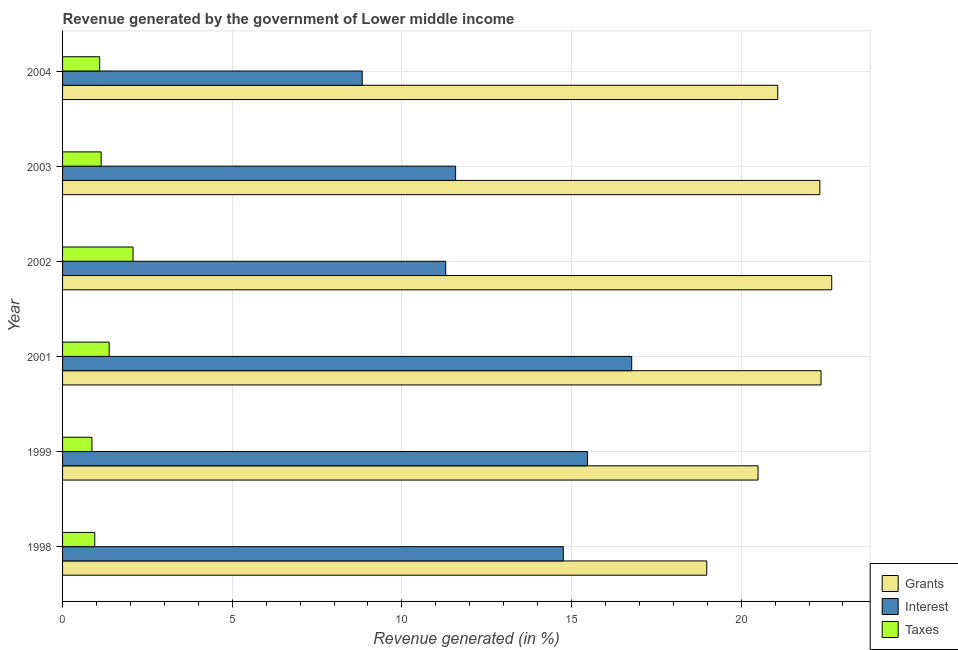How many different coloured bars are there?
Ensure brevity in your answer.  3. How many groups of bars are there?
Your answer should be compact. 6. How many bars are there on the 4th tick from the bottom?
Your answer should be very brief. 3. What is the label of the 4th group of bars from the top?
Your response must be concise. 2001. What is the percentage of revenue generated by taxes in 2003?
Offer a terse response. 1.14. Across all years, what is the maximum percentage of revenue generated by grants?
Your answer should be compact. 22.67. Across all years, what is the minimum percentage of revenue generated by grants?
Your response must be concise. 18.99. What is the total percentage of revenue generated by taxes in the graph?
Provide a succinct answer. 7.5. What is the difference between the percentage of revenue generated by grants in 1999 and that in 2003?
Your answer should be compact. -1.82. What is the difference between the percentage of revenue generated by taxes in 1998 and the percentage of revenue generated by grants in 1999?
Keep it short and to the point. -19.55. What is the average percentage of revenue generated by taxes per year?
Your answer should be very brief. 1.25. In the year 1999, what is the difference between the percentage of revenue generated by grants and percentage of revenue generated by interest?
Your answer should be compact. 5.03. In how many years, is the percentage of revenue generated by interest greater than 16 %?
Your answer should be compact. 1. What is the ratio of the percentage of revenue generated by taxes in 1999 to that in 2001?
Offer a very short reply. 0.63. Is the difference between the percentage of revenue generated by interest in 1999 and 2001 greater than the difference between the percentage of revenue generated by grants in 1999 and 2001?
Offer a very short reply. Yes. What is the difference between the highest and the second highest percentage of revenue generated by taxes?
Make the answer very short. 0.7. What is the difference between the highest and the lowest percentage of revenue generated by grants?
Provide a succinct answer. 3.68. Is the sum of the percentage of revenue generated by interest in 1998 and 2001 greater than the maximum percentage of revenue generated by taxes across all years?
Offer a terse response. Yes. What does the 1st bar from the top in 2004 represents?
Make the answer very short. Taxes. What does the 2nd bar from the bottom in 1998 represents?
Ensure brevity in your answer.  Interest. How many bars are there?
Your answer should be very brief. 18. Are all the bars in the graph horizontal?
Provide a short and direct response. Yes. How many years are there in the graph?
Provide a succinct answer. 6. What is the difference between two consecutive major ticks on the X-axis?
Make the answer very short. 5. Are the values on the major ticks of X-axis written in scientific E-notation?
Your response must be concise. No. Does the graph contain any zero values?
Provide a succinct answer. No. Where does the legend appear in the graph?
Make the answer very short. Bottom right. How many legend labels are there?
Your answer should be compact. 3. How are the legend labels stacked?
Your answer should be very brief. Vertical. What is the title of the graph?
Offer a terse response. Revenue generated by the government of Lower middle income. Does "Ages 50+" appear as one of the legend labels in the graph?
Provide a succinct answer. No. What is the label or title of the X-axis?
Make the answer very short. Revenue generated (in %). What is the Revenue generated (in %) of Grants in 1998?
Offer a terse response. 18.99. What is the Revenue generated (in %) of Interest in 1998?
Your answer should be very brief. 14.76. What is the Revenue generated (in %) of Taxes in 1998?
Your response must be concise. 0.95. What is the Revenue generated (in %) in Grants in 1999?
Your answer should be very brief. 20.5. What is the Revenue generated (in %) of Interest in 1999?
Your answer should be very brief. 15.47. What is the Revenue generated (in %) of Taxes in 1999?
Give a very brief answer. 0.87. What is the Revenue generated (in %) in Grants in 2001?
Make the answer very short. 22.35. What is the Revenue generated (in %) of Interest in 2001?
Keep it short and to the point. 16.77. What is the Revenue generated (in %) of Taxes in 2001?
Offer a very short reply. 1.37. What is the Revenue generated (in %) of Grants in 2002?
Make the answer very short. 22.67. What is the Revenue generated (in %) in Interest in 2002?
Ensure brevity in your answer.  11.29. What is the Revenue generated (in %) of Taxes in 2002?
Make the answer very short. 2.08. What is the Revenue generated (in %) in Grants in 2003?
Make the answer very short. 22.32. What is the Revenue generated (in %) of Interest in 2003?
Your answer should be very brief. 11.58. What is the Revenue generated (in %) of Taxes in 2003?
Ensure brevity in your answer.  1.14. What is the Revenue generated (in %) of Grants in 2004?
Your response must be concise. 21.08. What is the Revenue generated (in %) of Interest in 2004?
Make the answer very short. 8.83. What is the Revenue generated (in %) in Taxes in 2004?
Provide a short and direct response. 1.09. Across all years, what is the maximum Revenue generated (in %) in Grants?
Your answer should be very brief. 22.67. Across all years, what is the maximum Revenue generated (in %) of Interest?
Your answer should be very brief. 16.77. Across all years, what is the maximum Revenue generated (in %) in Taxes?
Give a very brief answer. 2.08. Across all years, what is the minimum Revenue generated (in %) of Grants?
Your answer should be compact. 18.99. Across all years, what is the minimum Revenue generated (in %) of Interest?
Ensure brevity in your answer.  8.83. Across all years, what is the minimum Revenue generated (in %) in Taxes?
Ensure brevity in your answer.  0.87. What is the total Revenue generated (in %) in Grants in the graph?
Ensure brevity in your answer.  127.9. What is the total Revenue generated (in %) in Interest in the graph?
Provide a succinct answer. 78.71. What is the total Revenue generated (in %) in Taxes in the graph?
Ensure brevity in your answer.  7.5. What is the difference between the Revenue generated (in %) in Grants in 1998 and that in 1999?
Provide a short and direct response. -1.51. What is the difference between the Revenue generated (in %) in Interest in 1998 and that in 1999?
Your answer should be very brief. -0.71. What is the difference between the Revenue generated (in %) of Taxes in 1998 and that in 1999?
Your answer should be very brief. 0.08. What is the difference between the Revenue generated (in %) in Grants in 1998 and that in 2001?
Ensure brevity in your answer.  -3.37. What is the difference between the Revenue generated (in %) of Interest in 1998 and that in 2001?
Your answer should be compact. -2.02. What is the difference between the Revenue generated (in %) in Taxes in 1998 and that in 2001?
Your answer should be very brief. -0.43. What is the difference between the Revenue generated (in %) of Grants in 1998 and that in 2002?
Ensure brevity in your answer.  -3.68. What is the difference between the Revenue generated (in %) of Interest in 1998 and that in 2002?
Offer a very short reply. 3.47. What is the difference between the Revenue generated (in %) in Taxes in 1998 and that in 2002?
Your response must be concise. -1.13. What is the difference between the Revenue generated (in %) of Grants in 1998 and that in 2003?
Provide a short and direct response. -3.33. What is the difference between the Revenue generated (in %) in Interest in 1998 and that in 2003?
Offer a very short reply. 3.17. What is the difference between the Revenue generated (in %) of Taxes in 1998 and that in 2003?
Provide a short and direct response. -0.19. What is the difference between the Revenue generated (in %) of Grants in 1998 and that in 2004?
Offer a terse response. -2.09. What is the difference between the Revenue generated (in %) of Interest in 1998 and that in 2004?
Offer a terse response. 5.93. What is the difference between the Revenue generated (in %) in Taxes in 1998 and that in 2004?
Offer a very short reply. -0.14. What is the difference between the Revenue generated (in %) of Grants in 1999 and that in 2001?
Your answer should be compact. -1.86. What is the difference between the Revenue generated (in %) of Interest in 1999 and that in 2001?
Your answer should be very brief. -1.3. What is the difference between the Revenue generated (in %) of Taxes in 1999 and that in 2001?
Your response must be concise. -0.51. What is the difference between the Revenue generated (in %) in Grants in 1999 and that in 2002?
Your response must be concise. -2.17. What is the difference between the Revenue generated (in %) of Interest in 1999 and that in 2002?
Your response must be concise. 4.18. What is the difference between the Revenue generated (in %) in Taxes in 1999 and that in 2002?
Your answer should be compact. -1.21. What is the difference between the Revenue generated (in %) of Grants in 1999 and that in 2003?
Provide a succinct answer. -1.82. What is the difference between the Revenue generated (in %) of Interest in 1999 and that in 2003?
Keep it short and to the point. 3.89. What is the difference between the Revenue generated (in %) in Taxes in 1999 and that in 2003?
Your response must be concise. -0.27. What is the difference between the Revenue generated (in %) of Grants in 1999 and that in 2004?
Keep it short and to the point. -0.58. What is the difference between the Revenue generated (in %) in Interest in 1999 and that in 2004?
Offer a terse response. 6.64. What is the difference between the Revenue generated (in %) in Taxes in 1999 and that in 2004?
Your response must be concise. -0.23. What is the difference between the Revenue generated (in %) of Grants in 2001 and that in 2002?
Ensure brevity in your answer.  -0.31. What is the difference between the Revenue generated (in %) in Interest in 2001 and that in 2002?
Provide a short and direct response. 5.48. What is the difference between the Revenue generated (in %) of Taxes in 2001 and that in 2002?
Keep it short and to the point. -0.7. What is the difference between the Revenue generated (in %) in Grants in 2001 and that in 2003?
Make the answer very short. 0.04. What is the difference between the Revenue generated (in %) of Interest in 2001 and that in 2003?
Your answer should be compact. 5.19. What is the difference between the Revenue generated (in %) in Taxes in 2001 and that in 2003?
Offer a terse response. 0.24. What is the difference between the Revenue generated (in %) of Grants in 2001 and that in 2004?
Your answer should be very brief. 1.28. What is the difference between the Revenue generated (in %) in Interest in 2001 and that in 2004?
Make the answer very short. 7.94. What is the difference between the Revenue generated (in %) in Taxes in 2001 and that in 2004?
Make the answer very short. 0.28. What is the difference between the Revenue generated (in %) of Grants in 2002 and that in 2003?
Keep it short and to the point. 0.35. What is the difference between the Revenue generated (in %) of Interest in 2002 and that in 2003?
Provide a succinct answer. -0.29. What is the difference between the Revenue generated (in %) of Taxes in 2002 and that in 2003?
Your answer should be very brief. 0.94. What is the difference between the Revenue generated (in %) in Grants in 2002 and that in 2004?
Your answer should be compact. 1.59. What is the difference between the Revenue generated (in %) in Interest in 2002 and that in 2004?
Provide a succinct answer. 2.46. What is the difference between the Revenue generated (in %) of Taxes in 2002 and that in 2004?
Your answer should be compact. 0.98. What is the difference between the Revenue generated (in %) in Grants in 2003 and that in 2004?
Provide a succinct answer. 1.24. What is the difference between the Revenue generated (in %) of Interest in 2003 and that in 2004?
Offer a very short reply. 2.75. What is the difference between the Revenue generated (in %) of Taxes in 2003 and that in 2004?
Provide a succinct answer. 0.04. What is the difference between the Revenue generated (in %) of Grants in 1998 and the Revenue generated (in %) of Interest in 1999?
Provide a short and direct response. 3.52. What is the difference between the Revenue generated (in %) in Grants in 1998 and the Revenue generated (in %) in Taxes in 1999?
Give a very brief answer. 18.12. What is the difference between the Revenue generated (in %) in Interest in 1998 and the Revenue generated (in %) in Taxes in 1999?
Ensure brevity in your answer.  13.89. What is the difference between the Revenue generated (in %) in Grants in 1998 and the Revenue generated (in %) in Interest in 2001?
Give a very brief answer. 2.21. What is the difference between the Revenue generated (in %) of Grants in 1998 and the Revenue generated (in %) of Taxes in 2001?
Give a very brief answer. 17.61. What is the difference between the Revenue generated (in %) of Interest in 1998 and the Revenue generated (in %) of Taxes in 2001?
Offer a terse response. 13.38. What is the difference between the Revenue generated (in %) of Grants in 1998 and the Revenue generated (in %) of Interest in 2002?
Keep it short and to the point. 7.69. What is the difference between the Revenue generated (in %) of Grants in 1998 and the Revenue generated (in %) of Taxes in 2002?
Ensure brevity in your answer.  16.91. What is the difference between the Revenue generated (in %) of Interest in 1998 and the Revenue generated (in %) of Taxes in 2002?
Your response must be concise. 12.68. What is the difference between the Revenue generated (in %) in Grants in 1998 and the Revenue generated (in %) in Interest in 2003?
Your answer should be compact. 7.4. What is the difference between the Revenue generated (in %) in Grants in 1998 and the Revenue generated (in %) in Taxes in 2003?
Ensure brevity in your answer.  17.85. What is the difference between the Revenue generated (in %) in Interest in 1998 and the Revenue generated (in %) in Taxes in 2003?
Offer a very short reply. 13.62. What is the difference between the Revenue generated (in %) in Grants in 1998 and the Revenue generated (in %) in Interest in 2004?
Make the answer very short. 10.15. What is the difference between the Revenue generated (in %) of Grants in 1998 and the Revenue generated (in %) of Taxes in 2004?
Give a very brief answer. 17.89. What is the difference between the Revenue generated (in %) of Interest in 1998 and the Revenue generated (in %) of Taxes in 2004?
Ensure brevity in your answer.  13.66. What is the difference between the Revenue generated (in %) in Grants in 1999 and the Revenue generated (in %) in Interest in 2001?
Your answer should be very brief. 3.72. What is the difference between the Revenue generated (in %) in Grants in 1999 and the Revenue generated (in %) in Taxes in 2001?
Your answer should be compact. 19.12. What is the difference between the Revenue generated (in %) of Interest in 1999 and the Revenue generated (in %) of Taxes in 2001?
Your response must be concise. 14.1. What is the difference between the Revenue generated (in %) in Grants in 1999 and the Revenue generated (in %) in Interest in 2002?
Your answer should be very brief. 9.21. What is the difference between the Revenue generated (in %) of Grants in 1999 and the Revenue generated (in %) of Taxes in 2002?
Give a very brief answer. 18.42. What is the difference between the Revenue generated (in %) in Interest in 1999 and the Revenue generated (in %) in Taxes in 2002?
Offer a very short reply. 13.39. What is the difference between the Revenue generated (in %) of Grants in 1999 and the Revenue generated (in %) of Interest in 2003?
Ensure brevity in your answer.  8.91. What is the difference between the Revenue generated (in %) in Grants in 1999 and the Revenue generated (in %) in Taxes in 2003?
Offer a very short reply. 19.36. What is the difference between the Revenue generated (in %) of Interest in 1999 and the Revenue generated (in %) of Taxes in 2003?
Your answer should be very brief. 14.33. What is the difference between the Revenue generated (in %) of Grants in 1999 and the Revenue generated (in %) of Interest in 2004?
Provide a succinct answer. 11.67. What is the difference between the Revenue generated (in %) of Grants in 1999 and the Revenue generated (in %) of Taxes in 2004?
Offer a very short reply. 19.4. What is the difference between the Revenue generated (in %) in Interest in 1999 and the Revenue generated (in %) in Taxes in 2004?
Provide a succinct answer. 14.38. What is the difference between the Revenue generated (in %) of Grants in 2001 and the Revenue generated (in %) of Interest in 2002?
Make the answer very short. 11.06. What is the difference between the Revenue generated (in %) of Grants in 2001 and the Revenue generated (in %) of Taxes in 2002?
Offer a very short reply. 20.28. What is the difference between the Revenue generated (in %) in Interest in 2001 and the Revenue generated (in %) in Taxes in 2002?
Ensure brevity in your answer.  14.7. What is the difference between the Revenue generated (in %) of Grants in 2001 and the Revenue generated (in %) of Interest in 2003?
Keep it short and to the point. 10.77. What is the difference between the Revenue generated (in %) of Grants in 2001 and the Revenue generated (in %) of Taxes in 2003?
Offer a very short reply. 21.22. What is the difference between the Revenue generated (in %) in Interest in 2001 and the Revenue generated (in %) in Taxes in 2003?
Offer a very short reply. 15.64. What is the difference between the Revenue generated (in %) in Grants in 2001 and the Revenue generated (in %) in Interest in 2004?
Make the answer very short. 13.52. What is the difference between the Revenue generated (in %) in Grants in 2001 and the Revenue generated (in %) in Taxes in 2004?
Provide a succinct answer. 21.26. What is the difference between the Revenue generated (in %) in Interest in 2001 and the Revenue generated (in %) in Taxes in 2004?
Make the answer very short. 15.68. What is the difference between the Revenue generated (in %) of Grants in 2002 and the Revenue generated (in %) of Interest in 2003?
Offer a very short reply. 11.09. What is the difference between the Revenue generated (in %) in Grants in 2002 and the Revenue generated (in %) in Taxes in 2003?
Keep it short and to the point. 21.53. What is the difference between the Revenue generated (in %) of Interest in 2002 and the Revenue generated (in %) of Taxes in 2003?
Your response must be concise. 10.16. What is the difference between the Revenue generated (in %) of Grants in 2002 and the Revenue generated (in %) of Interest in 2004?
Give a very brief answer. 13.84. What is the difference between the Revenue generated (in %) in Grants in 2002 and the Revenue generated (in %) in Taxes in 2004?
Keep it short and to the point. 21.58. What is the difference between the Revenue generated (in %) of Interest in 2002 and the Revenue generated (in %) of Taxes in 2004?
Ensure brevity in your answer.  10.2. What is the difference between the Revenue generated (in %) in Grants in 2003 and the Revenue generated (in %) in Interest in 2004?
Offer a terse response. 13.49. What is the difference between the Revenue generated (in %) in Grants in 2003 and the Revenue generated (in %) in Taxes in 2004?
Ensure brevity in your answer.  21.23. What is the difference between the Revenue generated (in %) of Interest in 2003 and the Revenue generated (in %) of Taxes in 2004?
Your answer should be very brief. 10.49. What is the average Revenue generated (in %) of Grants per year?
Ensure brevity in your answer.  21.32. What is the average Revenue generated (in %) of Interest per year?
Offer a terse response. 13.12. What is the average Revenue generated (in %) of Taxes per year?
Provide a short and direct response. 1.25. In the year 1998, what is the difference between the Revenue generated (in %) of Grants and Revenue generated (in %) of Interest?
Offer a terse response. 4.23. In the year 1998, what is the difference between the Revenue generated (in %) in Grants and Revenue generated (in %) in Taxes?
Keep it short and to the point. 18.04. In the year 1998, what is the difference between the Revenue generated (in %) of Interest and Revenue generated (in %) of Taxes?
Provide a succinct answer. 13.81. In the year 1999, what is the difference between the Revenue generated (in %) in Grants and Revenue generated (in %) in Interest?
Offer a very short reply. 5.03. In the year 1999, what is the difference between the Revenue generated (in %) of Grants and Revenue generated (in %) of Taxes?
Give a very brief answer. 19.63. In the year 1999, what is the difference between the Revenue generated (in %) of Interest and Revenue generated (in %) of Taxes?
Offer a terse response. 14.6. In the year 2001, what is the difference between the Revenue generated (in %) of Grants and Revenue generated (in %) of Interest?
Your response must be concise. 5.58. In the year 2001, what is the difference between the Revenue generated (in %) in Grants and Revenue generated (in %) in Taxes?
Give a very brief answer. 20.98. In the year 2001, what is the difference between the Revenue generated (in %) in Interest and Revenue generated (in %) in Taxes?
Give a very brief answer. 15.4. In the year 2002, what is the difference between the Revenue generated (in %) in Grants and Revenue generated (in %) in Interest?
Give a very brief answer. 11.38. In the year 2002, what is the difference between the Revenue generated (in %) in Grants and Revenue generated (in %) in Taxes?
Your response must be concise. 20.59. In the year 2002, what is the difference between the Revenue generated (in %) of Interest and Revenue generated (in %) of Taxes?
Make the answer very short. 9.22. In the year 2003, what is the difference between the Revenue generated (in %) in Grants and Revenue generated (in %) in Interest?
Provide a succinct answer. 10.74. In the year 2003, what is the difference between the Revenue generated (in %) in Grants and Revenue generated (in %) in Taxes?
Your answer should be very brief. 21.18. In the year 2003, what is the difference between the Revenue generated (in %) of Interest and Revenue generated (in %) of Taxes?
Keep it short and to the point. 10.45. In the year 2004, what is the difference between the Revenue generated (in %) in Grants and Revenue generated (in %) in Interest?
Provide a short and direct response. 12.25. In the year 2004, what is the difference between the Revenue generated (in %) of Grants and Revenue generated (in %) of Taxes?
Your response must be concise. 19.98. In the year 2004, what is the difference between the Revenue generated (in %) of Interest and Revenue generated (in %) of Taxes?
Provide a short and direct response. 7.74. What is the ratio of the Revenue generated (in %) of Grants in 1998 to that in 1999?
Keep it short and to the point. 0.93. What is the ratio of the Revenue generated (in %) in Interest in 1998 to that in 1999?
Your answer should be compact. 0.95. What is the ratio of the Revenue generated (in %) of Taxes in 1998 to that in 1999?
Offer a very short reply. 1.1. What is the ratio of the Revenue generated (in %) of Grants in 1998 to that in 2001?
Make the answer very short. 0.85. What is the ratio of the Revenue generated (in %) of Interest in 1998 to that in 2001?
Give a very brief answer. 0.88. What is the ratio of the Revenue generated (in %) in Taxes in 1998 to that in 2001?
Ensure brevity in your answer.  0.69. What is the ratio of the Revenue generated (in %) in Grants in 1998 to that in 2002?
Keep it short and to the point. 0.84. What is the ratio of the Revenue generated (in %) of Interest in 1998 to that in 2002?
Make the answer very short. 1.31. What is the ratio of the Revenue generated (in %) in Taxes in 1998 to that in 2002?
Offer a very short reply. 0.46. What is the ratio of the Revenue generated (in %) of Grants in 1998 to that in 2003?
Offer a very short reply. 0.85. What is the ratio of the Revenue generated (in %) of Interest in 1998 to that in 2003?
Offer a very short reply. 1.27. What is the ratio of the Revenue generated (in %) in Taxes in 1998 to that in 2003?
Your response must be concise. 0.83. What is the ratio of the Revenue generated (in %) of Grants in 1998 to that in 2004?
Offer a very short reply. 0.9. What is the ratio of the Revenue generated (in %) of Interest in 1998 to that in 2004?
Offer a terse response. 1.67. What is the ratio of the Revenue generated (in %) in Taxes in 1998 to that in 2004?
Your response must be concise. 0.87. What is the ratio of the Revenue generated (in %) of Grants in 1999 to that in 2001?
Give a very brief answer. 0.92. What is the ratio of the Revenue generated (in %) of Interest in 1999 to that in 2001?
Ensure brevity in your answer.  0.92. What is the ratio of the Revenue generated (in %) in Taxes in 1999 to that in 2001?
Your response must be concise. 0.63. What is the ratio of the Revenue generated (in %) in Grants in 1999 to that in 2002?
Provide a succinct answer. 0.9. What is the ratio of the Revenue generated (in %) in Interest in 1999 to that in 2002?
Provide a succinct answer. 1.37. What is the ratio of the Revenue generated (in %) in Taxes in 1999 to that in 2002?
Offer a very short reply. 0.42. What is the ratio of the Revenue generated (in %) in Grants in 1999 to that in 2003?
Ensure brevity in your answer.  0.92. What is the ratio of the Revenue generated (in %) of Interest in 1999 to that in 2003?
Offer a terse response. 1.34. What is the ratio of the Revenue generated (in %) in Taxes in 1999 to that in 2003?
Give a very brief answer. 0.76. What is the ratio of the Revenue generated (in %) in Grants in 1999 to that in 2004?
Provide a succinct answer. 0.97. What is the ratio of the Revenue generated (in %) in Interest in 1999 to that in 2004?
Your answer should be compact. 1.75. What is the ratio of the Revenue generated (in %) in Taxes in 1999 to that in 2004?
Your answer should be very brief. 0.79. What is the ratio of the Revenue generated (in %) of Grants in 2001 to that in 2002?
Offer a very short reply. 0.99. What is the ratio of the Revenue generated (in %) of Interest in 2001 to that in 2002?
Make the answer very short. 1.49. What is the ratio of the Revenue generated (in %) of Taxes in 2001 to that in 2002?
Provide a succinct answer. 0.66. What is the ratio of the Revenue generated (in %) in Interest in 2001 to that in 2003?
Your answer should be very brief. 1.45. What is the ratio of the Revenue generated (in %) of Taxes in 2001 to that in 2003?
Offer a terse response. 1.21. What is the ratio of the Revenue generated (in %) of Grants in 2001 to that in 2004?
Your response must be concise. 1.06. What is the ratio of the Revenue generated (in %) in Interest in 2001 to that in 2004?
Give a very brief answer. 1.9. What is the ratio of the Revenue generated (in %) of Taxes in 2001 to that in 2004?
Offer a terse response. 1.26. What is the ratio of the Revenue generated (in %) in Grants in 2002 to that in 2003?
Give a very brief answer. 1.02. What is the ratio of the Revenue generated (in %) of Interest in 2002 to that in 2003?
Ensure brevity in your answer.  0.97. What is the ratio of the Revenue generated (in %) in Taxes in 2002 to that in 2003?
Provide a succinct answer. 1.83. What is the ratio of the Revenue generated (in %) in Grants in 2002 to that in 2004?
Your answer should be very brief. 1.08. What is the ratio of the Revenue generated (in %) of Interest in 2002 to that in 2004?
Provide a short and direct response. 1.28. What is the ratio of the Revenue generated (in %) of Taxes in 2002 to that in 2004?
Offer a terse response. 1.9. What is the ratio of the Revenue generated (in %) of Grants in 2003 to that in 2004?
Ensure brevity in your answer.  1.06. What is the ratio of the Revenue generated (in %) in Interest in 2003 to that in 2004?
Your answer should be compact. 1.31. What is the ratio of the Revenue generated (in %) of Taxes in 2003 to that in 2004?
Provide a succinct answer. 1.04. What is the difference between the highest and the second highest Revenue generated (in %) in Grants?
Provide a succinct answer. 0.31. What is the difference between the highest and the second highest Revenue generated (in %) of Interest?
Offer a very short reply. 1.3. What is the difference between the highest and the second highest Revenue generated (in %) of Taxes?
Offer a very short reply. 0.7. What is the difference between the highest and the lowest Revenue generated (in %) in Grants?
Make the answer very short. 3.68. What is the difference between the highest and the lowest Revenue generated (in %) in Interest?
Ensure brevity in your answer.  7.94. What is the difference between the highest and the lowest Revenue generated (in %) in Taxes?
Offer a very short reply. 1.21. 